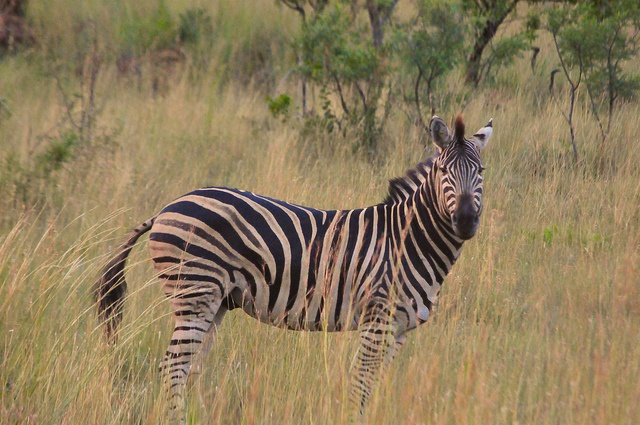Describe the objects in this image and their specific colors. I can see a zebra in maroon, black, tan, and gray tones in this image. 